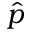Convert formula to latex. <formula><loc_0><loc_0><loc_500><loc_500>\hat { p }</formula> 